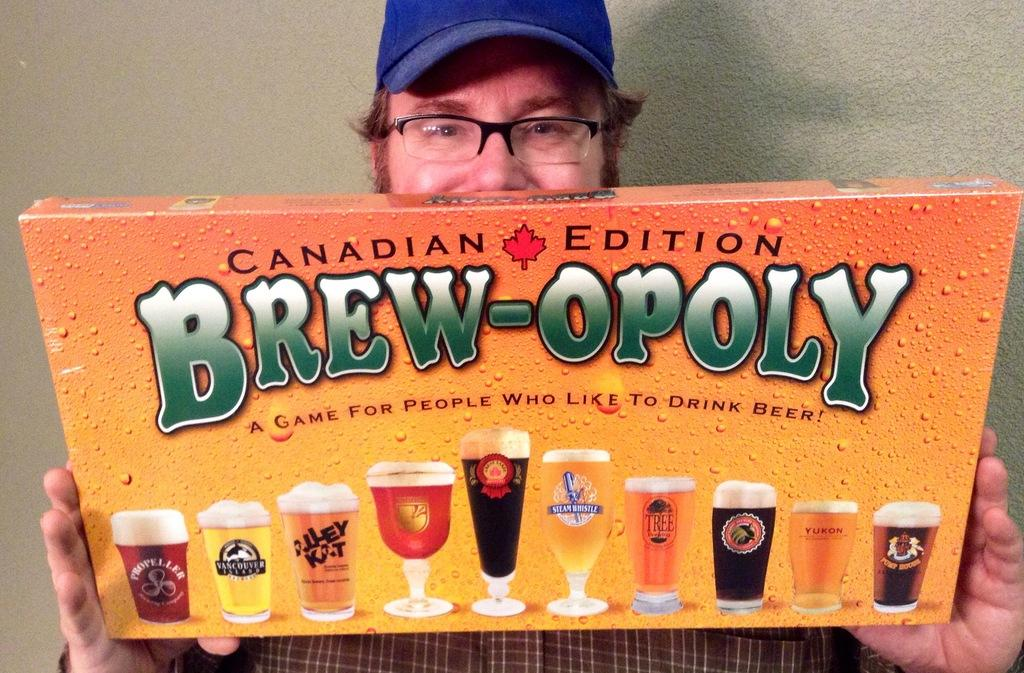<image>
Render a clear and concise summary of the photo. A man holds up a box containing the game Brew-opoly. 